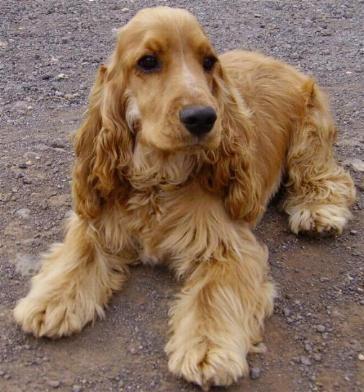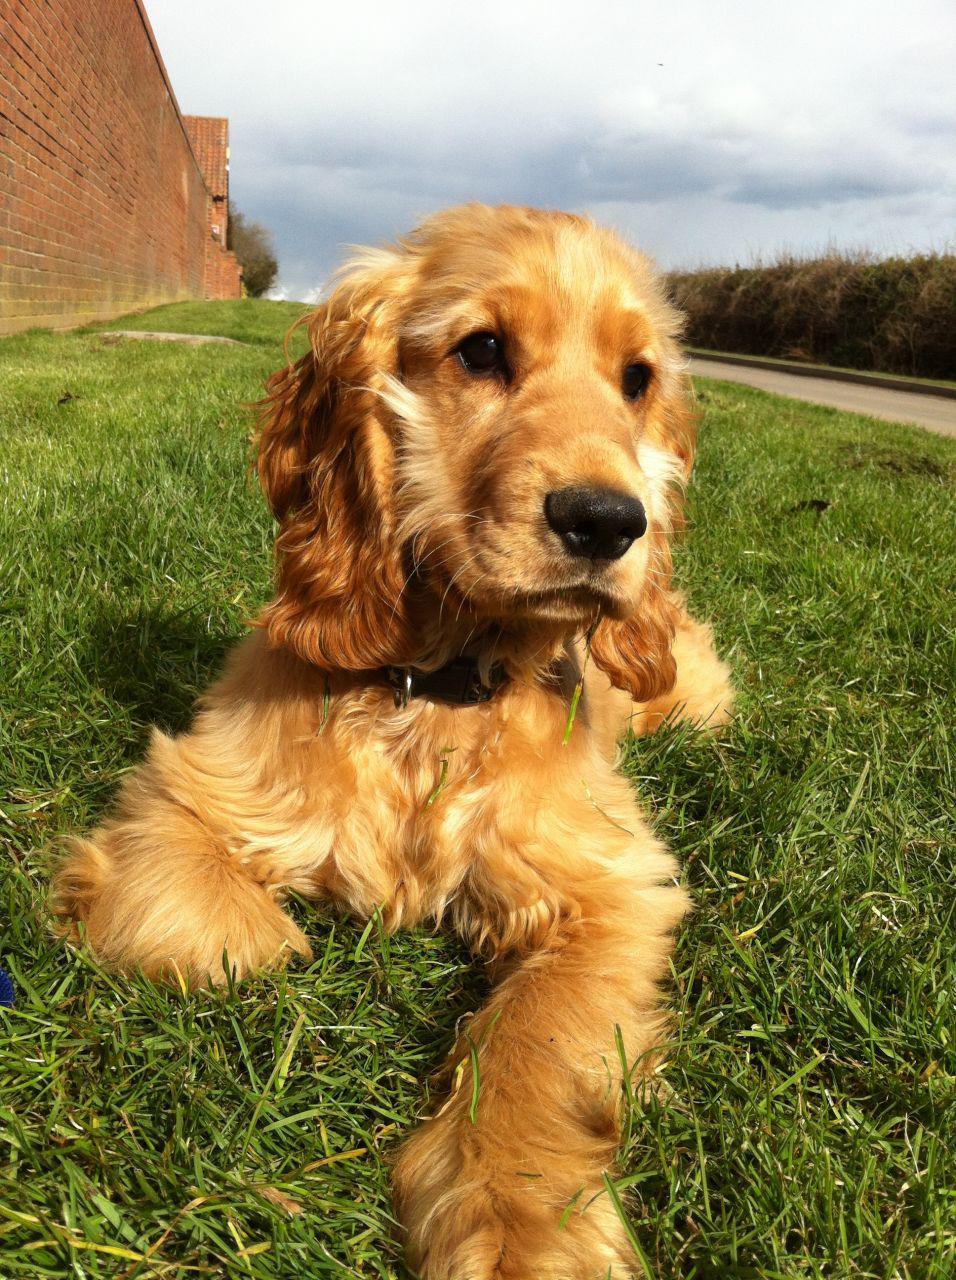The first image is the image on the left, the second image is the image on the right. Given the left and right images, does the statement "A total of two dogs are shown, with none of them standing." hold true? Answer yes or no. Yes. The first image is the image on the left, the second image is the image on the right. For the images displayed, is the sentence "The sky can be seen in the background of one of the images." factually correct? Answer yes or no. Yes. 